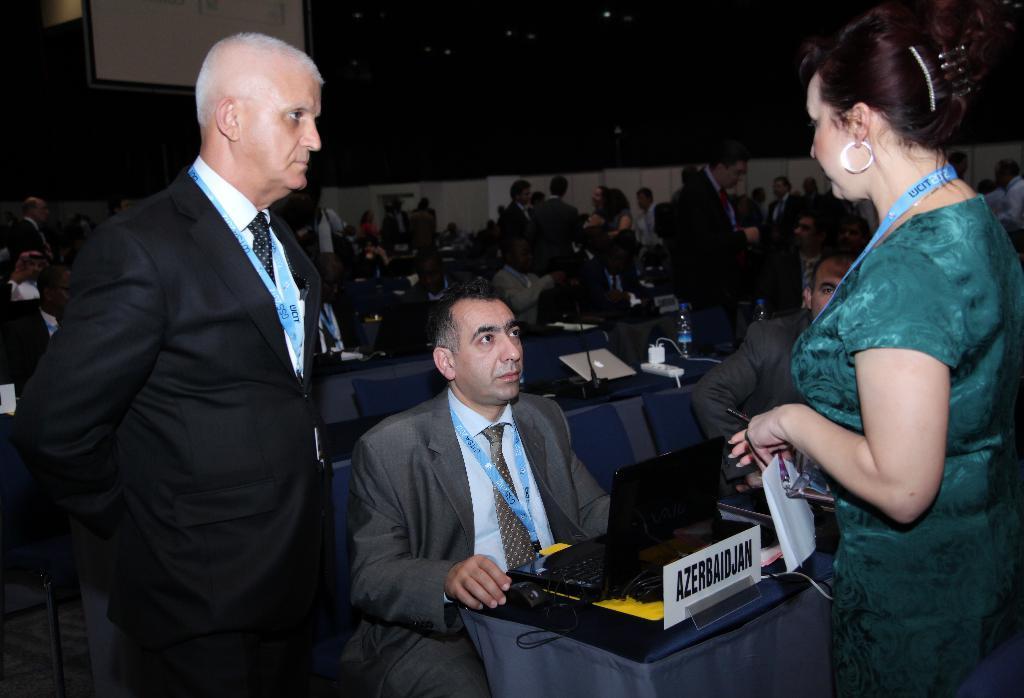How would you summarize this image in a sentence or two? In this image we can see many people. There are few people are sitting and few are standing in the image. There are many objects placed on the tables. There are few people wearing an identity card. 